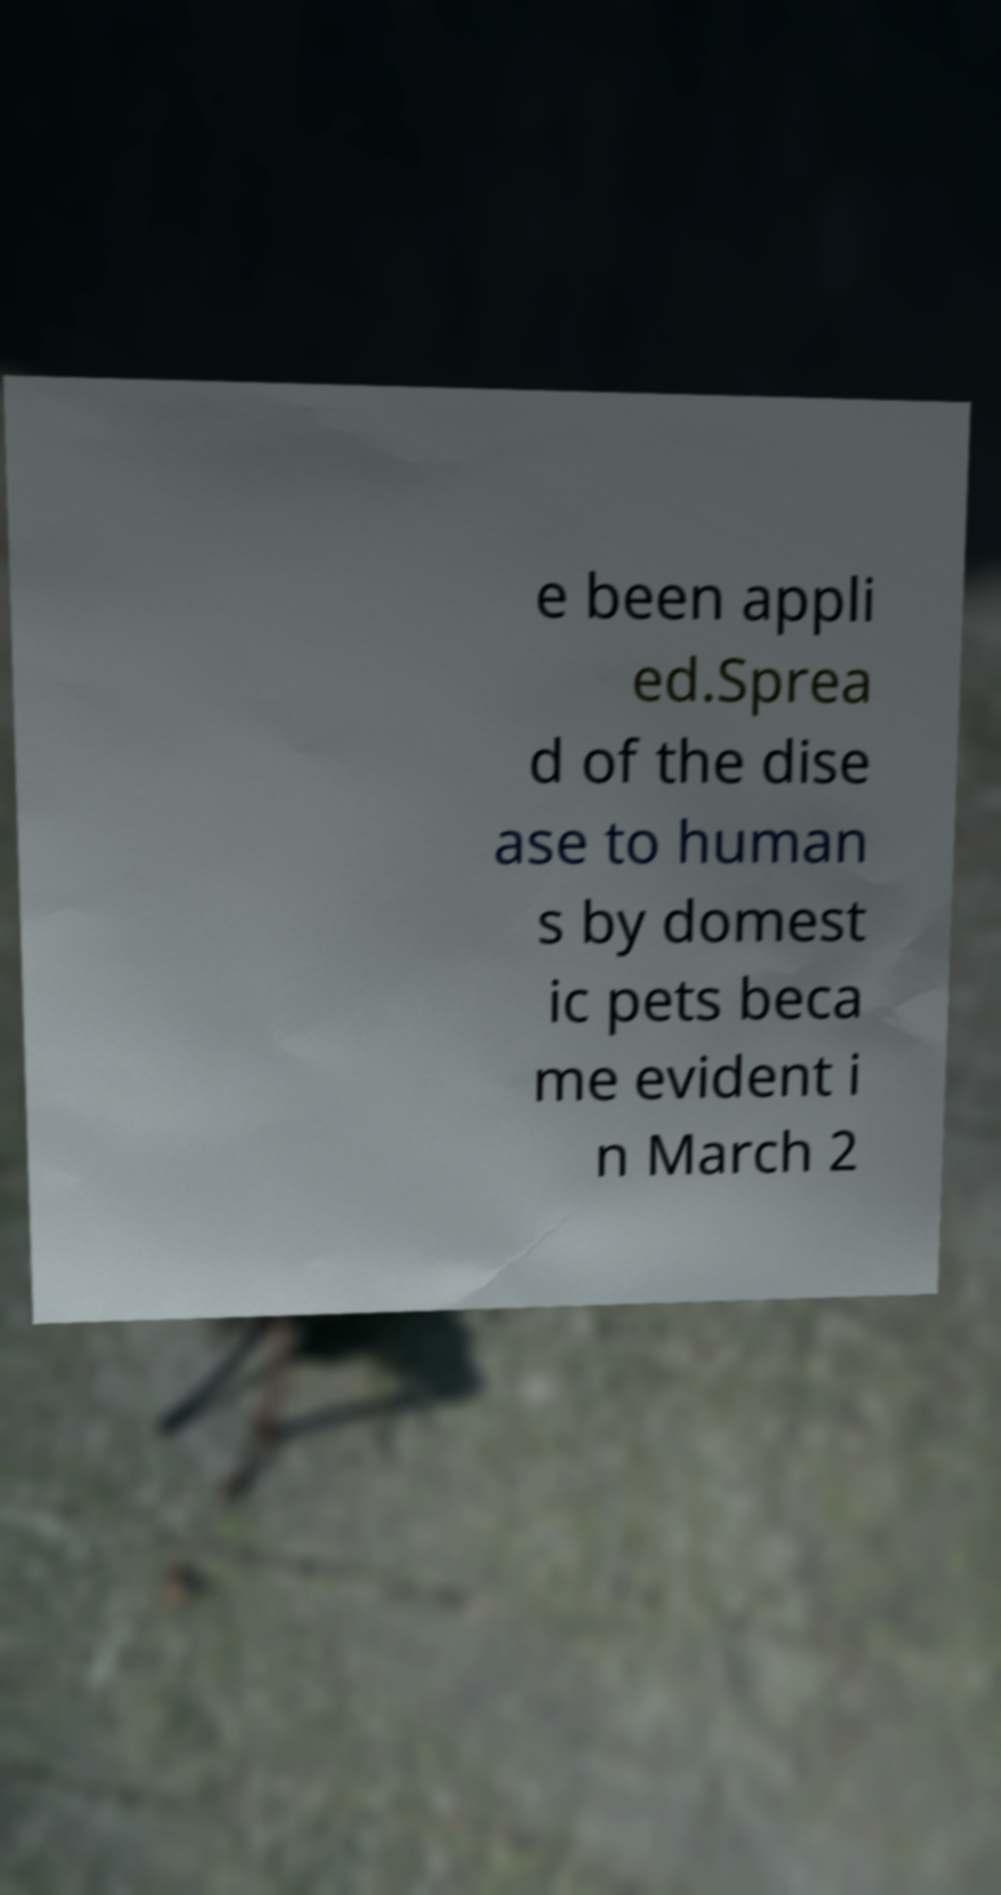Could you extract and type out the text from this image? e been appli ed.Sprea d of the dise ase to human s by domest ic pets beca me evident i n March 2 